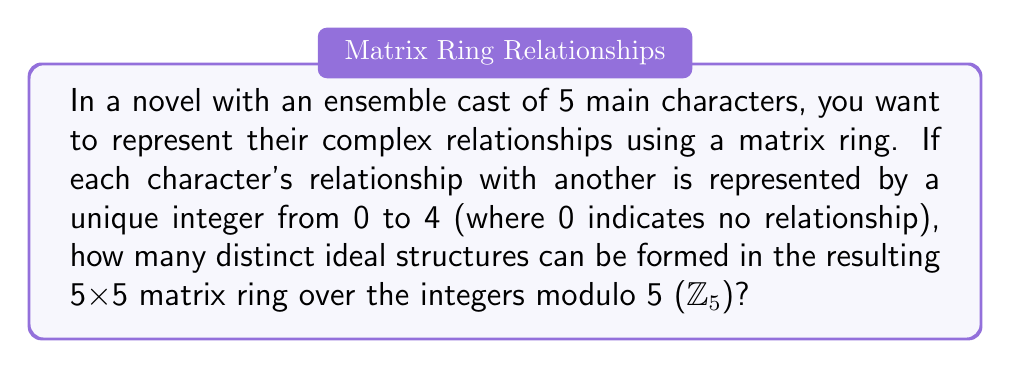Give your solution to this math problem. To solve this problem, we need to follow these steps:

1) First, we need to understand what we're working with. We have a 5x5 matrix ring over $\mathbb{Z}_5$. This means each entry in the matrix can be 0, 1, 2, 3, or 4.

2) In a matrix ring, ideals are subsets that are closed under addition and multiplication by any element of the ring. In our case, we're particularly interested in two-sided ideals.

3) For a matrix ring over a field (which $\mathbb{Z}_5$ is), the two-sided ideals have a specific structure. They are of the form:

   $$\left\{\begin{pmatrix} 
   A & B \\
   0 & 0
   \end{pmatrix} : A \in M_k(\mathbb{Z}_5), B \in M_{k \times (5-k)}(\mathbb{Z}_5)\right\}$$

   where $k$ can be 0, 1, 2, 3, 4, or 5.

4) The number of distinct ideal structures is equal to the number of possible values for $k$, which is 6 in this case.

5) These ideals correspond to different ways the characters can be grouped:
   - $k=0$: No relationships (trivial ideal)
   - $k=1$: One character related to others
   - $k=2$: Two characters forming a subgroup
   - $k=3$: Three characters forming a subgroup
   - $k=4$: Four characters forming a subgroup
   - $k=5$: All characters related (the entire ring)

6) Each of these structures represents a unique way the characters can be interconnected in the story, from completely isolated to fully intertwined.

Therefore, there are 6 distinct ideal structures in this matrix ring.
Answer: 6 distinct ideal structures 